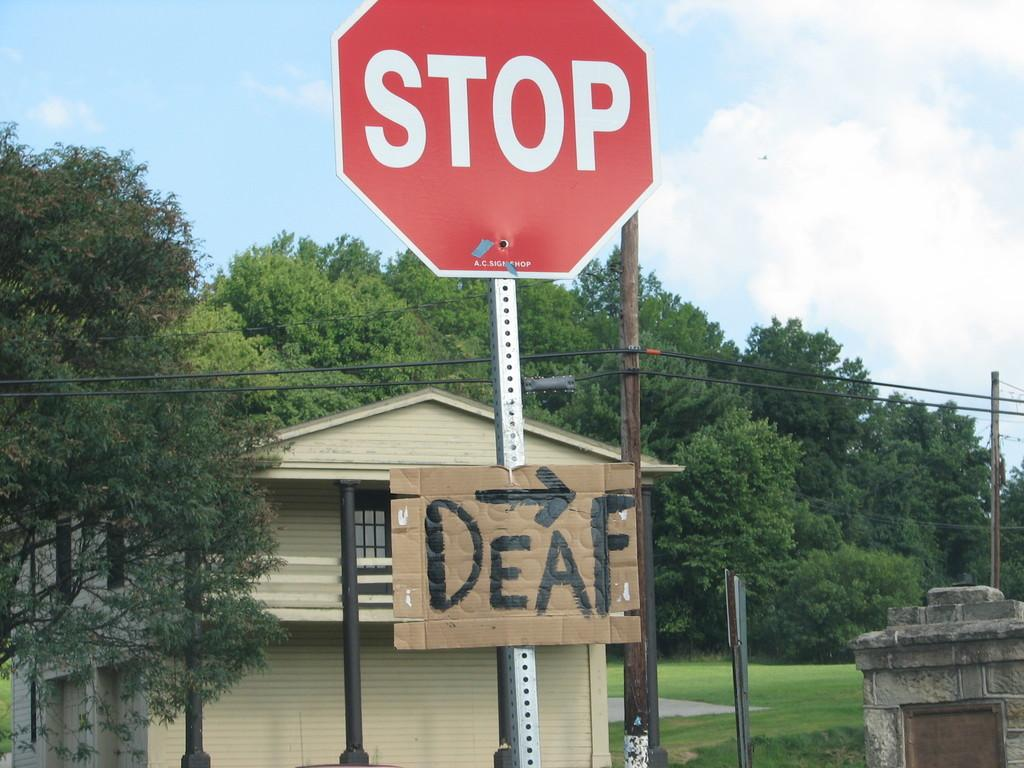<image>
Share a concise interpretation of the image provided. a hand made cardboard sign with the words deaf and drawn arrow under a stop sign 